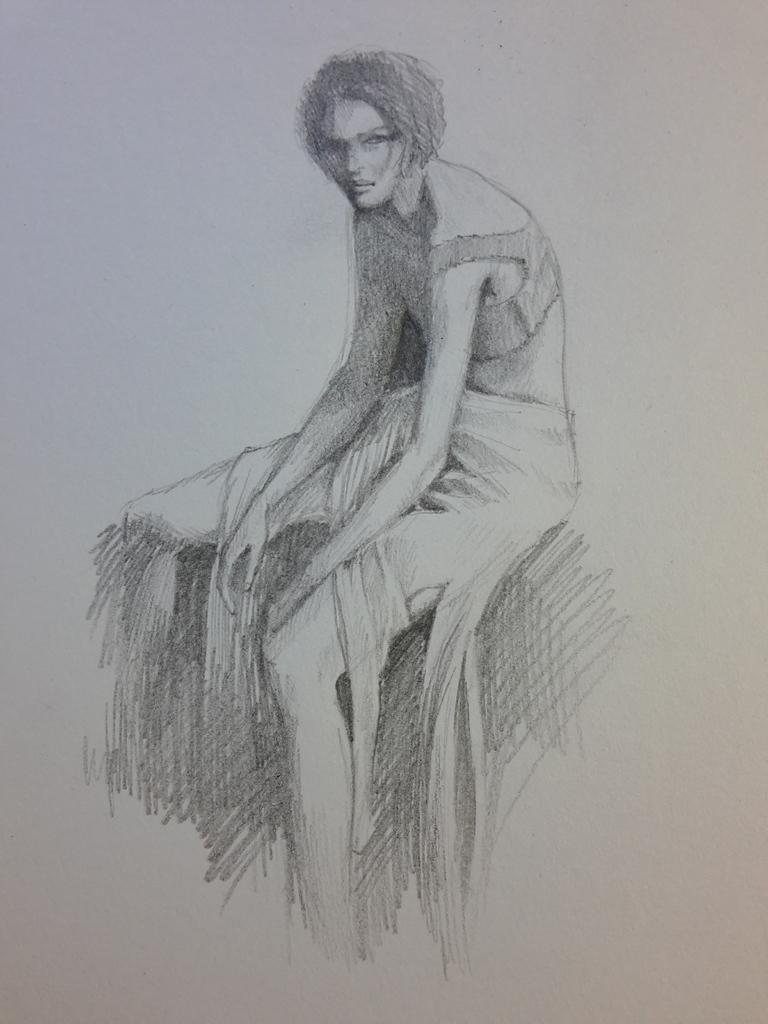Please provide a concise description of this image. In this image I can see a white colour thing and on it I can see sketch of a person. I can see colour of this sketch is black and white. 